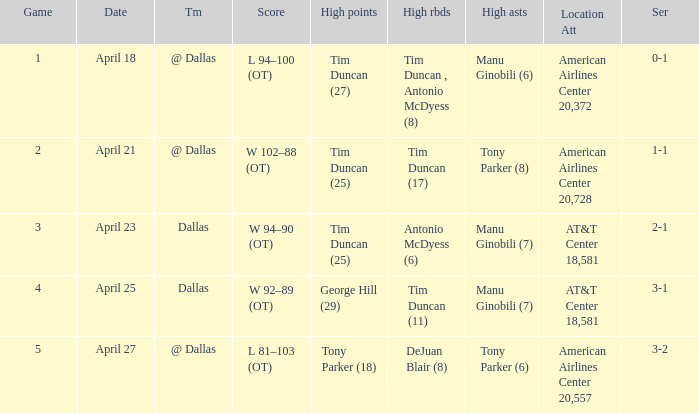When 1-1 is the series who is the team? @ Dallas. 